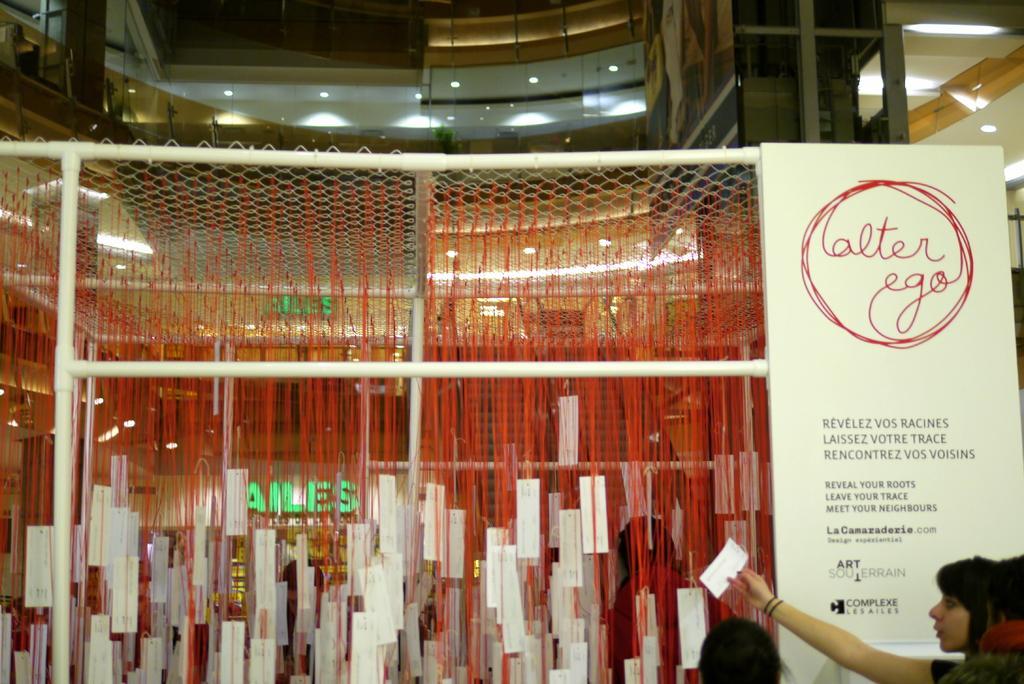How would you summarize this image in a sentence or two? This picture describes about group of people, beside to the persons we can see a hoarding, metal rods, net and few papers, in the background we can find few lights and buildings. 